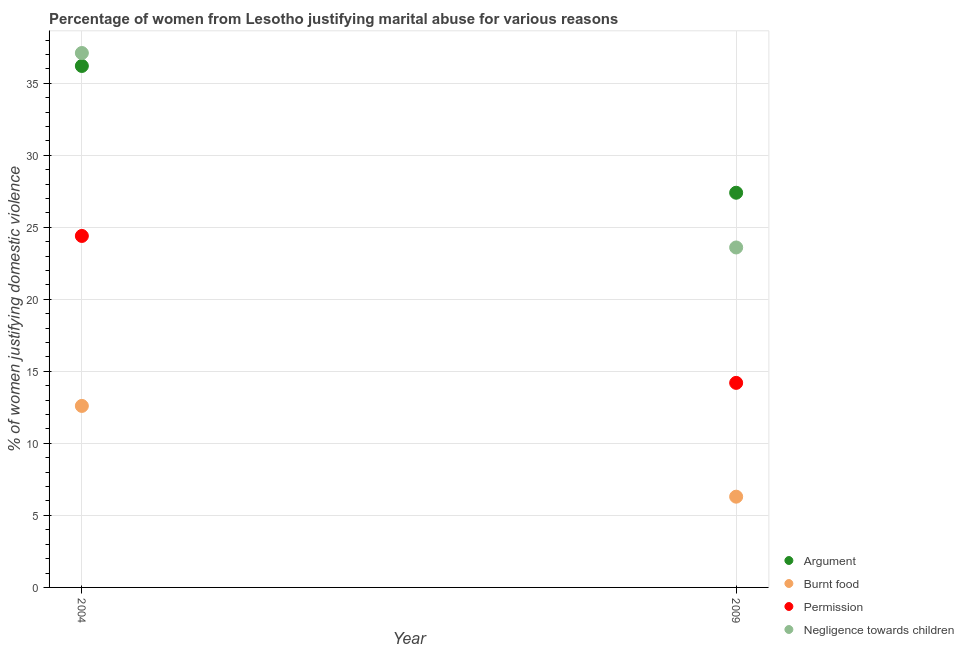Is the number of dotlines equal to the number of legend labels?
Give a very brief answer. Yes. Across all years, what is the maximum percentage of women justifying abuse in the case of an argument?
Your answer should be very brief. 36.2. Across all years, what is the minimum percentage of women justifying abuse for showing negligence towards children?
Offer a very short reply. 23.6. What is the total percentage of women justifying abuse in the case of an argument in the graph?
Your answer should be compact. 63.6. What is the difference between the percentage of women justifying abuse for going without permission in 2009 and the percentage of women justifying abuse for burning food in 2004?
Provide a succinct answer. 1.6. What is the average percentage of women justifying abuse for going without permission per year?
Give a very brief answer. 19.3. In the year 2009, what is the difference between the percentage of women justifying abuse for going without permission and percentage of women justifying abuse for burning food?
Ensure brevity in your answer.  7.9. In how many years, is the percentage of women justifying abuse for burning food greater than 7 %?
Make the answer very short. 1. What is the ratio of the percentage of women justifying abuse for showing negligence towards children in 2004 to that in 2009?
Make the answer very short. 1.57. Is the percentage of women justifying abuse for going without permission in 2004 less than that in 2009?
Your answer should be compact. No. Is it the case that in every year, the sum of the percentage of women justifying abuse for burning food and percentage of women justifying abuse for showing negligence towards children is greater than the sum of percentage of women justifying abuse in the case of an argument and percentage of women justifying abuse for going without permission?
Offer a terse response. No. Is it the case that in every year, the sum of the percentage of women justifying abuse in the case of an argument and percentage of women justifying abuse for burning food is greater than the percentage of women justifying abuse for going without permission?
Ensure brevity in your answer.  Yes. How many years are there in the graph?
Give a very brief answer. 2. What is the difference between two consecutive major ticks on the Y-axis?
Your answer should be compact. 5. Does the graph contain grids?
Provide a succinct answer. Yes. How many legend labels are there?
Ensure brevity in your answer.  4. How are the legend labels stacked?
Provide a short and direct response. Vertical. What is the title of the graph?
Provide a short and direct response. Percentage of women from Lesotho justifying marital abuse for various reasons. Does "Revenue mobilization" appear as one of the legend labels in the graph?
Give a very brief answer. No. What is the label or title of the X-axis?
Offer a very short reply. Year. What is the label or title of the Y-axis?
Offer a terse response. % of women justifying domestic violence. What is the % of women justifying domestic violence of Argument in 2004?
Provide a succinct answer. 36.2. What is the % of women justifying domestic violence of Permission in 2004?
Offer a very short reply. 24.4. What is the % of women justifying domestic violence of Negligence towards children in 2004?
Your response must be concise. 37.1. What is the % of women justifying domestic violence in Argument in 2009?
Offer a very short reply. 27.4. What is the % of women justifying domestic violence of Permission in 2009?
Your answer should be compact. 14.2. What is the % of women justifying domestic violence in Negligence towards children in 2009?
Offer a very short reply. 23.6. Across all years, what is the maximum % of women justifying domestic violence of Argument?
Your answer should be very brief. 36.2. Across all years, what is the maximum % of women justifying domestic violence of Permission?
Offer a terse response. 24.4. Across all years, what is the maximum % of women justifying domestic violence in Negligence towards children?
Offer a terse response. 37.1. Across all years, what is the minimum % of women justifying domestic violence in Argument?
Give a very brief answer. 27.4. Across all years, what is the minimum % of women justifying domestic violence of Negligence towards children?
Give a very brief answer. 23.6. What is the total % of women justifying domestic violence in Argument in the graph?
Make the answer very short. 63.6. What is the total % of women justifying domestic violence in Burnt food in the graph?
Keep it short and to the point. 18.9. What is the total % of women justifying domestic violence of Permission in the graph?
Your response must be concise. 38.6. What is the total % of women justifying domestic violence of Negligence towards children in the graph?
Your answer should be compact. 60.7. What is the difference between the % of women justifying domestic violence of Argument in 2004 and that in 2009?
Your response must be concise. 8.8. What is the difference between the % of women justifying domestic violence of Argument in 2004 and the % of women justifying domestic violence of Burnt food in 2009?
Ensure brevity in your answer.  29.9. What is the difference between the % of women justifying domestic violence of Argument in 2004 and the % of women justifying domestic violence of Permission in 2009?
Ensure brevity in your answer.  22. What is the difference between the % of women justifying domestic violence in Burnt food in 2004 and the % of women justifying domestic violence in Permission in 2009?
Offer a terse response. -1.6. What is the difference between the % of women justifying domestic violence of Burnt food in 2004 and the % of women justifying domestic violence of Negligence towards children in 2009?
Offer a terse response. -11. What is the difference between the % of women justifying domestic violence in Permission in 2004 and the % of women justifying domestic violence in Negligence towards children in 2009?
Provide a short and direct response. 0.8. What is the average % of women justifying domestic violence in Argument per year?
Your answer should be very brief. 31.8. What is the average % of women justifying domestic violence of Burnt food per year?
Provide a succinct answer. 9.45. What is the average % of women justifying domestic violence in Permission per year?
Give a very brief answer. 19.3. What is the average % of women justifying domestic violence in Negligence towards children per year?
Provide a short and direct response. 30.35. In the year 2004, what is the difference between the % of women justifying domestic violence of Argument and % of women justifying domestic violence of Burnt food?
Your response must be concise. 23.6. In the year 2004, what is the difference between the % of women justifying domestic violence of Argument and % of women justifying domestic violence of Permission?
Provide a short and direct response. 11.8. In the year 2004, what is the difference between the % of women justifying domestic violence of Argument and % of women justifying domestic violence of Negligence towards children?
Your response must be concise. -0.9. In the year 2004, what is the difference between the % of women justifying domestic violence of Burnt food and % of women justifying domestic violence of Negligence towards children?
Offer a terse response. -24.5. In the year 2009, what is the difference between the % of women justifying domestic violence in Argument and % of women justifying domestic violence in Burnt food?
Your response must be concise. 21.1. In the year 2009, what is the difference between the % of women justifying domestic violence in Argument and % of women justifying domestic violence in Permission?
Provide a succinct answer. 13.2. In the year 2009, what is the difference between the % of women justifying domestic violence of Argument and % of women justifying domestic violence of Negligence towards children?
Ensure brevity in your answer.  3.8. In the year 2009, what is the difference between the % of women justifying domestic violence in Burnt food and % of women justifying domestic violence in Permission?
Keep it short and to the point. -7.9. In the year 2009, what is the difference between the % of women justifying domestic violence of Burnt food and % of women justifying domestic violence of Negligence towards children?
Your answer should be compact. -17.3. What is the ratio of the % of women justifying domestic violence of Argument in 2004 to that in 2009?
Offer a terse response. 1.32. What is the ratio of the % of women justifying domestic violence of Permission in 2004 to that in 2009?
Offer a very short reply. 1.72. What is the ratio of the % of women justifying domestic violence in Negligence towards children in 2004 to that in 2009?
Ensure brevity in your answer.  1.57. What is the difference between the highest and the second highest % of women justifying domestic violence in Argument?
Offer a terse response. 8.8. What is the difference between the highest and the lowest % of women justifying domestic violence in Permission?
Make the answer very short. 10.2. What is the difference between the highest and the lowest % of women justifying domestic violence of Negligence towards children?
Offer a terse response. 13.5. 